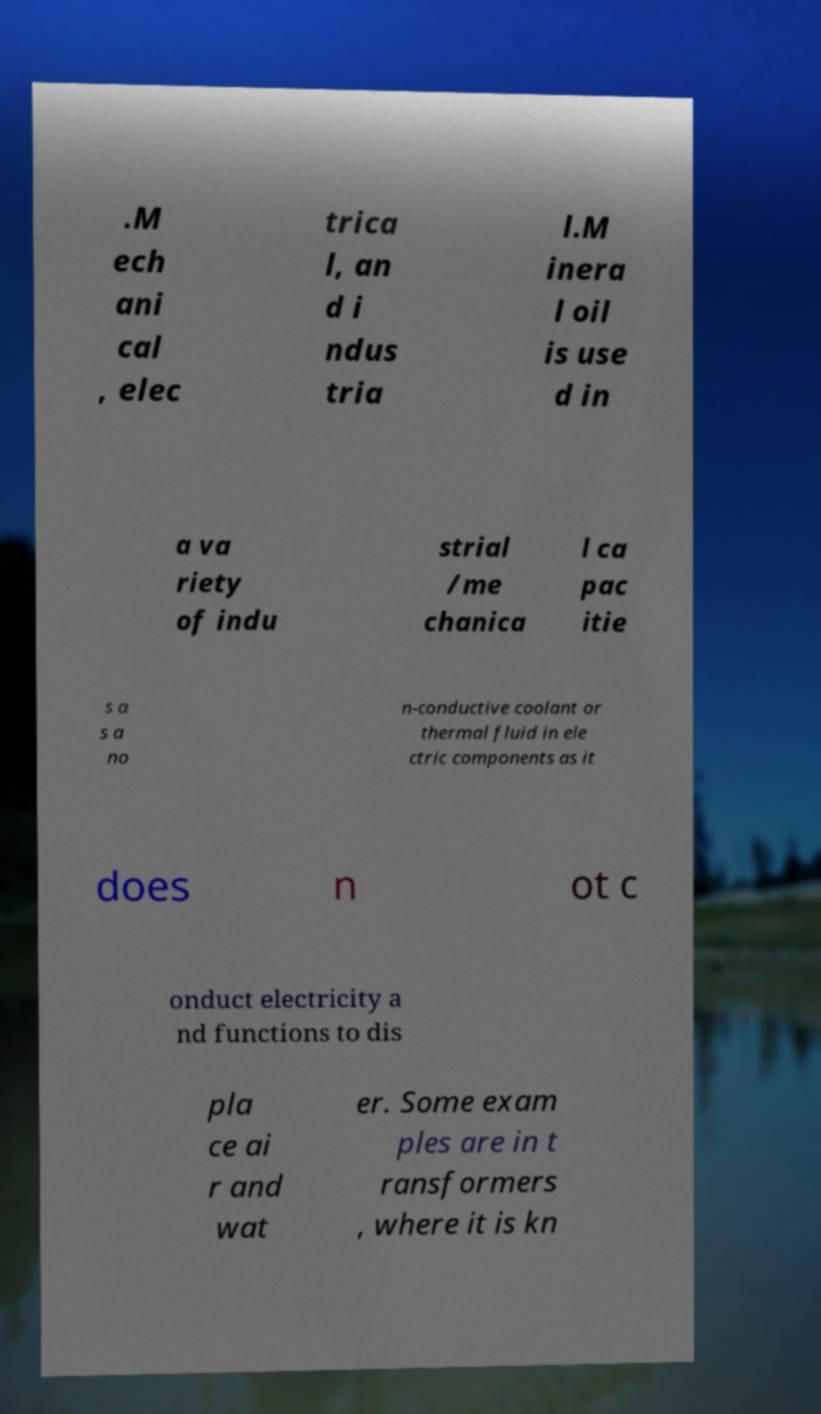For documentation purposes, I need the text within this image transcribed. Could you provide that? .M ech ani cal , elec trica l, an d i ndus tria l.M inera l oil is use d in a va riety of indu strial /me chanica l ca pac itie s a s a no n-conductive coolant or thermal fluid in ele ctric components as it does n ot c onduct electricity a nd functions to dis pla ce ai r and wat er. Some exam ples are in t ransformers , where it is kn 